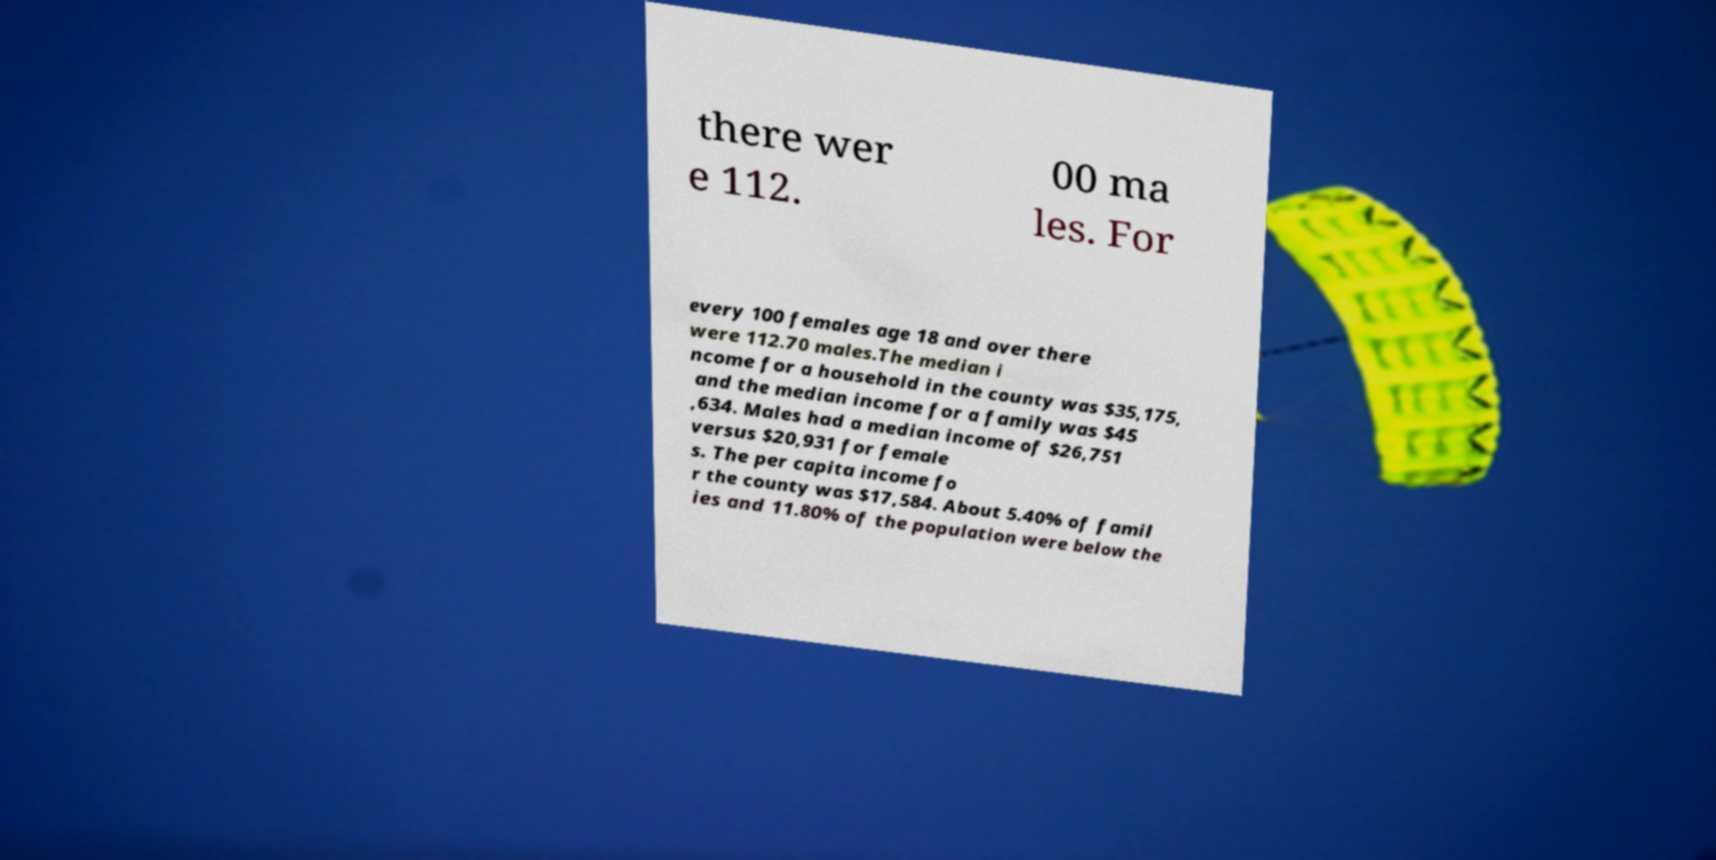Could you extract and type out the text from this image? there wer e 112. 00 ma les. For every 100 females age 18 and over there were 112.70 males.The median i ncome for a household in the county was $35,175, and the median income for a family was $45 ,634. Males had a median income of $26,751 versus $20,931 for female s. The per capita income fo r the county was $17,584. About 5.40% of famil ies and 11.80% of the population were below the 